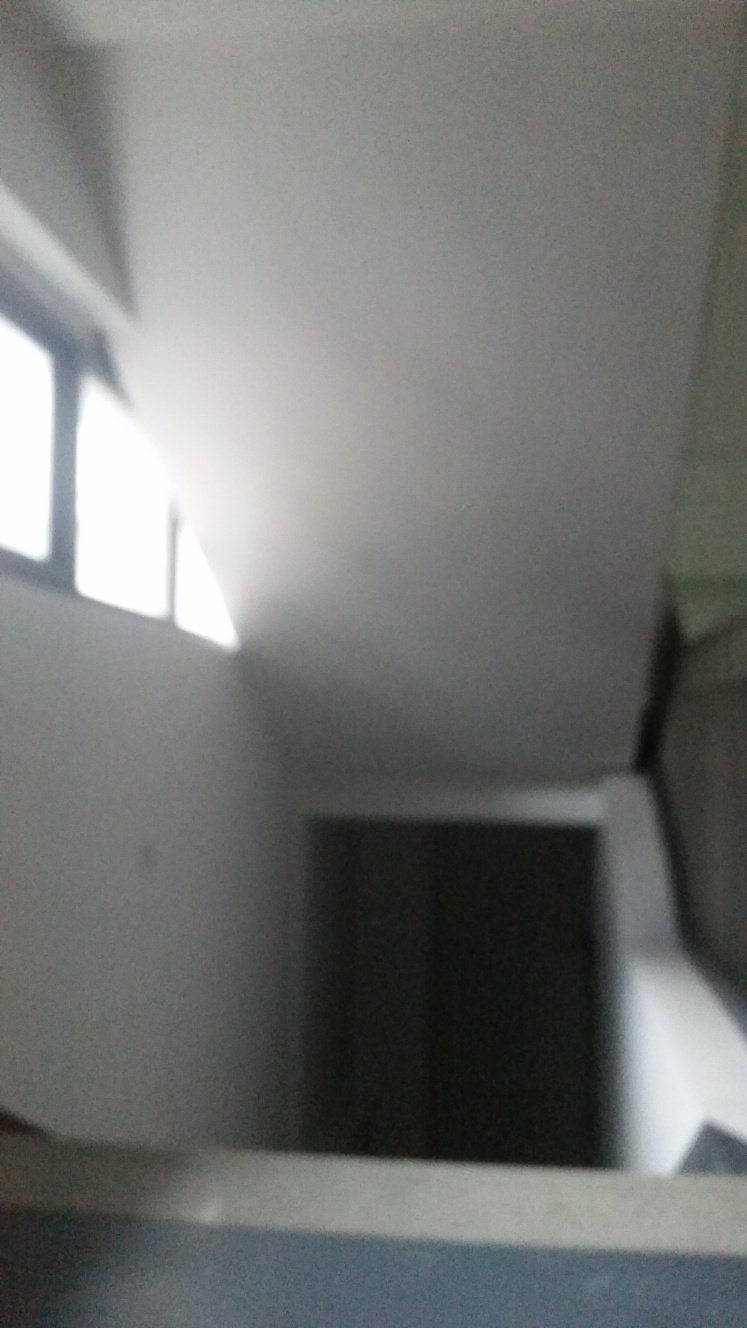What could be the cause of the blurriness in this image? The blurriness in the image is likely due to a combination of a shaky camera and low lighting conditions. Improper focus settings or a rapid camera movement during the shot can also contribute to the blurriness. 